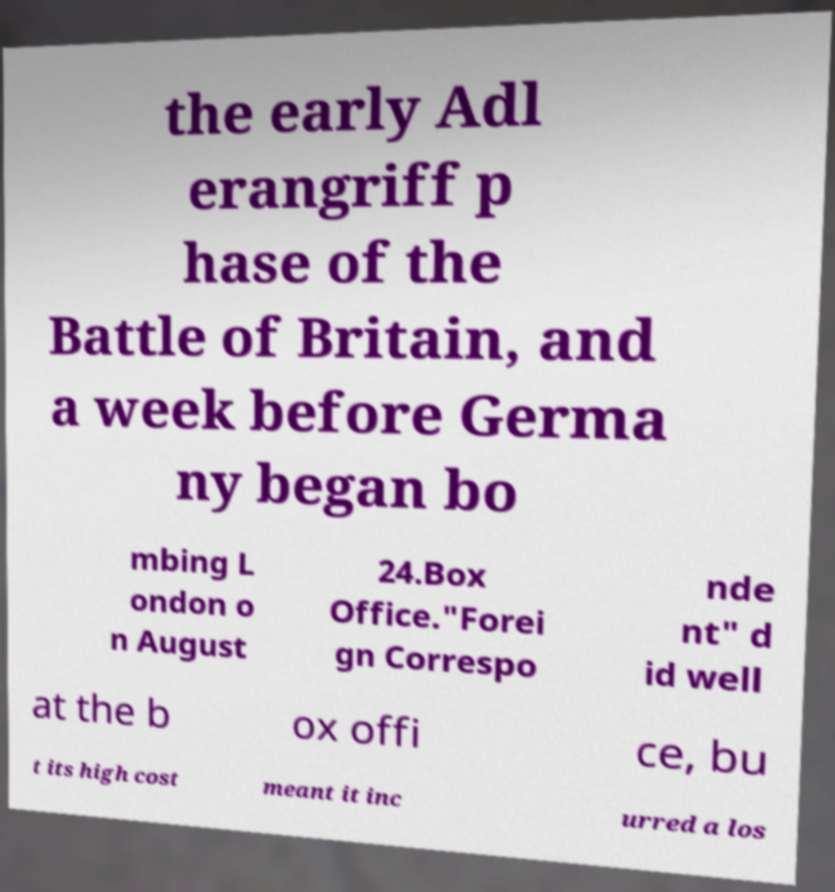There's text embedded in this image that I need extracted. Can you transcribe it verbatim? the early Adl erangriff p hase of the Battle of Britain, and a week before Germa ny began bo mbing L ondon o n August 24.Box Office."Forei gn Correspo nde nt" d id well at the b ox offi ce, bu t its high cost meant it inc urred a los 